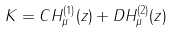Convert formula to latex. <formula><loc_0><loc_0><loc_500><loc_500>K = C H _ { \mu } ^ { ( 1 ) } ( z ) + D H _ { \mu } ^ { ( 2 ) } ( z )</formula> 